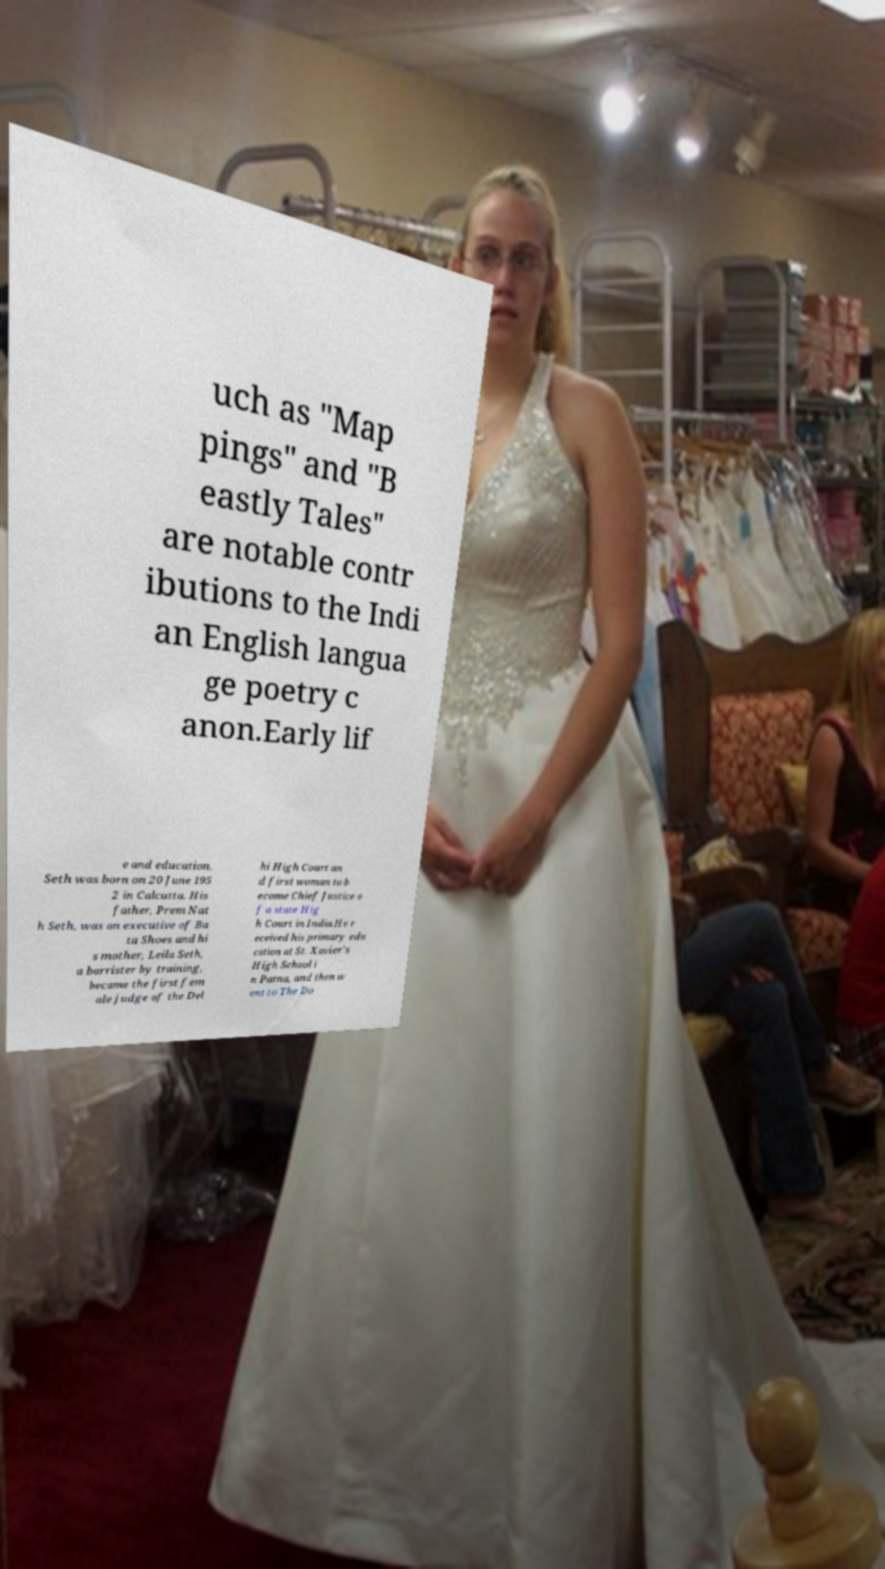For documentation purposes, I need the text within this image transcribed. Could you provide that? uch as "Map pings" and "B eastly Tales" are notable contr ibutions to the Indi an English langua ge poetry c anon.Early lif e and education. Seth was born on 20 June 195 2 in Calcutta. His father, Prem Nat h Seth, was an executive of Ba ta Shoes and hi s mother, Leila Seth, a barrister by training, became the first fem ale judge of the Del hi High Court an d first woman to b ecome Chief Justice o f a state Hig h Court in India.He r eceived his primary edu cation at St. Xavier's High School i n Patna, and then w ent to The Do 